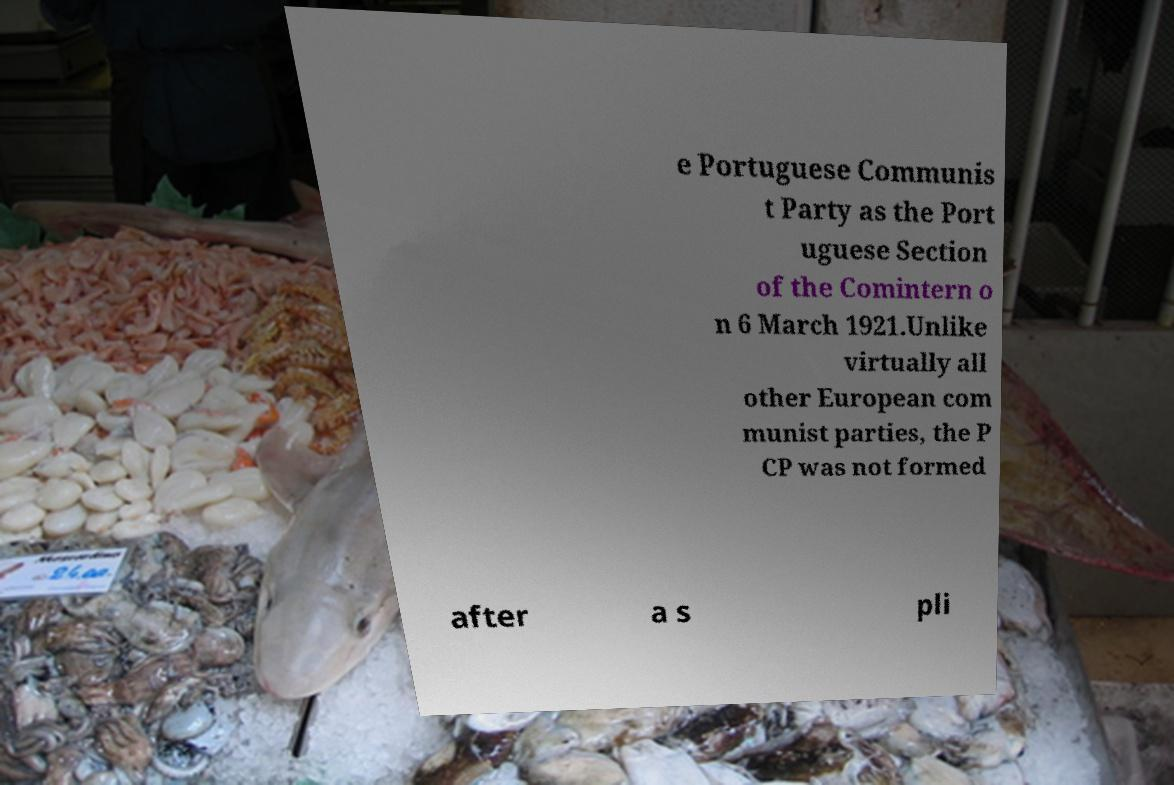I need the written content from this picture converted into text. Can you do that? e Portuguese Communis t Party as the Port uguese Section of the Comintern o n 6 March 1921.Unlike virtually all other European com munist parties, the P CP was not formed after a s pli 